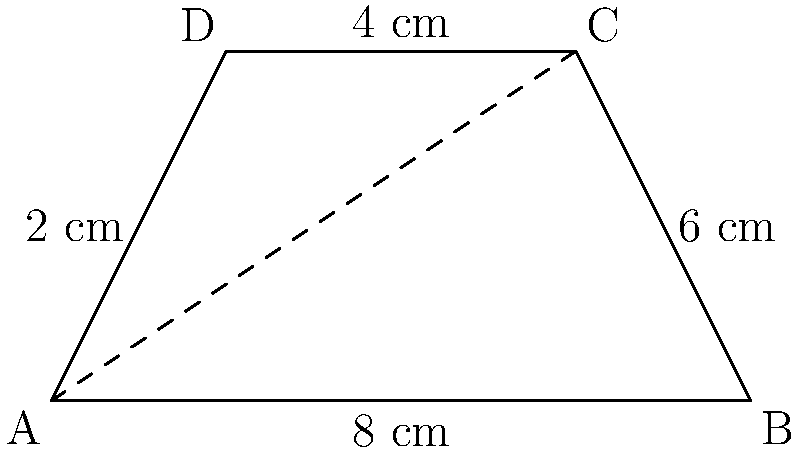As a fashion stylist, you're designing a trapezoid-shaped panel for a dress that creates vertical movement. The panel has parallel sides of 2 cm and 6 cm, with a height of 4 cm. Calculate the area of this dress panel in square centimeters. To calculate the area of a trapezoid, we use the formula:

$$A = \frac{1}{2}(b_1 + b_2)h$$

Where:
$A$ = Area
$b_1$ and $b_2$ = Lengths of the parallel sides
$h$ = Height (perpendicular distance between the parallel sides)

Given:
$b_1 = 2$ cm
$b_2 = 6$ cm
$h = 4$ cm

Substituting these values into the formula:

$$A = \frac{1}{2}(2 + 6) \times 4$$

$$A = \frac{1}{2}(8) \times 4$$

$$A = 4 \times 4$$

$$A = 16$$

Therefore, the area of the trapezoid-shaped dress panel is 16 square centimeters.
Answer: 16 cm² 